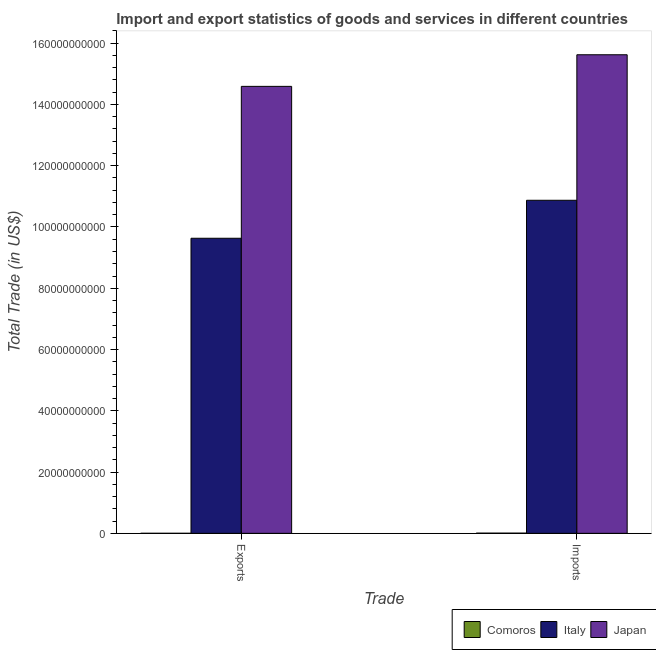Are the number of bars on each tick of the X-axis equal?
Your response must be concise. Yes. How many bars are there on the 1st tick from the right?
Your answer should be very brief. 3. What is the label of the 2nd group of bars from the left?
Offer a very short reply. Imports. What is the imports of goods and services in Italy?
Provide a succinct answer. 1.09e+11. Across all countries, what is the maximum imports of goods and services?
Make the answer very short. 1.56e+11. Across all countries, what is the minimum imports of goods and services?
Provide a succinct answer. 6.42e+07. In which country was the imports of goods and services minimum?
Ensure brevity in your answer.  Comoros. What is the total export of goods and services in the graph?
Give a very brief answer. 2.42e+11. What is the difference between the export of goods and services in Japan and that in Italy?
Make the answer very short. 4.96e+1. What is the difference between the imports of goods and services in Japan and the export of goods and services in Italy?
Make the answer very short. 5.99e+1. What is the average export of goods and services per country?
Make the answer very short. 8.07e+1. What is the difference between the imports of goods and services and export of goods and services in Italy?
Offer a terse response. 1.24e+1. What is the ratio of the imports of goods and services in Japan to that in Comoros?
Keep it short and to the point. 2435.19. In how many countries, is the export of goods and services greater than the average export of goods and services taken over all countries?
Your answer should be very brief. 2. What does the 1st bar from the left in Exports represents?
Keep it short and to the point. Comoros. How many bars are there?
Your answer should be very brief. 6. Are the values on the major ticks of Y-axis written in scientific E-notation?
Provide a succinct answer. No. Does the graph contain grids?
Ensure brevity in your answer.  No. How are the legend labels stacked?
Your answer should be compact. Horizontal. What is the title of the graph?
Your answer should be very brief. Import and export statistics of goods and services in different countries. What is the label or title of the X-axis?
Provide a short and direct response. Trade. What is the label or title of the Y-axis?
Offer a terse response. Total Trade (in US$). What is the Total Trade (in US$) of Comoros in Exports?
Offer a very short reply. 1.07e+07. What is the Total Trade (in US$) in Italy in Exports?
Provide a short and direct response. 9.63e+1. What is the Total Trade (in US$) in Japan in Exports?
Make the answer very short. 1.46e+11. What is the Total Trade (in US$) of Comoros in Imports?
Offer a very short reply. 6.42e+07. What is the Total Trade (in US$) in Italy in Imports?
Ensure brevity in your answer.  1.09e+11. What is the Total Trade (in US$) of Japan in Imports?
Your answer should be very brief. 1.56e+11. Across all Trade, what is the maximum Total Trade (in US$) of Comoros?
Give a very brief answer. 6.42e+07. Across all Trade, what is the maximum Total Trade (in US$) of Italy?
Ensure brevity in your answer.  1.09e+11. Across all Trade, what is the maximum Total Trade (in US$) in Japan?
Provide a short and direct response. 1.56e+11. Across all Trade, what is the minimum Total Trade (in US$) of Comoros?
Your answer should be very brief. 1.07e+07. Across all Trade, what is the minimum Total Trade (in US$) of Italy?
Provide a succinct answer. 9.63e+1. Across all Trade, what is the minimum Total Trade (in US$) of Japan?
Offer a terse response. 1.46e+11. What is the total Total Trade (in US$) of Comoros in the graph?
Ensure brevity in your answer.  7.49e+07. What is the total Total Trade (in US$) in Italy in the graph?
Keep it short and to the point. 2.05e+11. What is the total Total Trade (in US$) in Japan in the graph?
Provide a short and direct response. 3.02e+11. What is the difference between the Total Trade (in US$) of Comoros in Exports and that in Imports?
Your response must be concise. -5.34e+07. What is the difference between the Total Trade (in US$) of Italy in Exports and that in Imports?
Your answer should be very brief. -1.24e+1. What is the difference between the Total Trade (in US$) of Japan in Exports and that in Imports?
Ensure brevity in your answer.  -1.03e+1. What is the difference between the Total Trade (in US$) of Comoros in Exports and the Total Trade (in US$) of Italy in Imports?
Your answer should be very brief. -1.09e+11. What is the difference between the Total Trade (in US$) of Comoros in Exports and the Total Trade (in US$) of Japan in Imports?
Provide a short and direct response. -1.56e+11. What is the difference between the Total Trade (in US$) of Italy in Exports and the Total Trade (in US$) of Japan in Imports?
Provide a short and direct response. -5.99e+1. What is the average Total Trade (in US$) in Comoros per Trade?
Offer a terse response. 3.74e+07. What is the average Total Trade (in US$) of Italy per Trade?
Keep it short and to the point. 1.03e+11. What is the average Total Trade (in US$) in Japan per Trade?
Your response must be concise. 1.51e+11. What is the difference between the Total Trade (in US$) of Comoros and Total Trade (in US$) of Italy in Exports?
Your response must be concise. -9.63e+1. What is the difference between the Total Trade (in US$) of Comoros and Total Trade (in US$) of Japan in Exports?
Provide a short and direct response. -1.46e+11. What is the difference between the Total Trade (in US$) of Italy and Total Trade (in US$) of Japan in Exports?
Make the answer very short. -4.96e+1. What is the difference between the Total Trade (in US$) of Comoros and Total Trade (in US$) of Italy in Imports?
Your answer should be very brief. -1.09e+11. What is the difference between the Total Trade (in US$) of Comoros and Total Trade (in US$) of Japan in Imports?
Provide a succinct answer. -1.56e+11. What is the difference between the Total Trade (in US$) of Italy and Total Trade (in US$) of Japan in Imports?
Make the answer very short. -4.75e+1. What is the ratio of the Total Trade (in US$) of Comoros in Exports to that in Imports?
Your answer should be very brief. 0.17. What is the ratio of the Total Trade (in US$) of Italy in Exports to that in Imports?
Your response must be concise. 0.89. What is the ratio of the Total Trade (in US$) in Japan in Exports to that in Imports?
Your answer should be compact. 0.93. What is the difference between the highest and the second highest Total Trade (in US$) of Comoros?
Your answer should be very brief. 5.34e+07. What is the difference between the highest and the second highest Total Trade (in US$) of Italy?
Keep it short and to the point. 1.24e+1. What is the difference between the highest and the second highest Total Trade (in US$) in Japan?
Ensure brevity in your answer.  1.03e+1. What is the difference between the highest and the lowest Total Trade (in US$) of Comoros?
Your answer should be compact. 5.34e+07. What is the difference between the highest and the lowest Total Trade (in US$) of Italy?
Make the answer very short. 1.24e+1. What is the difference between the highest and the lowest Total Trade (in US$) in Japan?
Ensure brevity in your answer.  1.03e+1. 